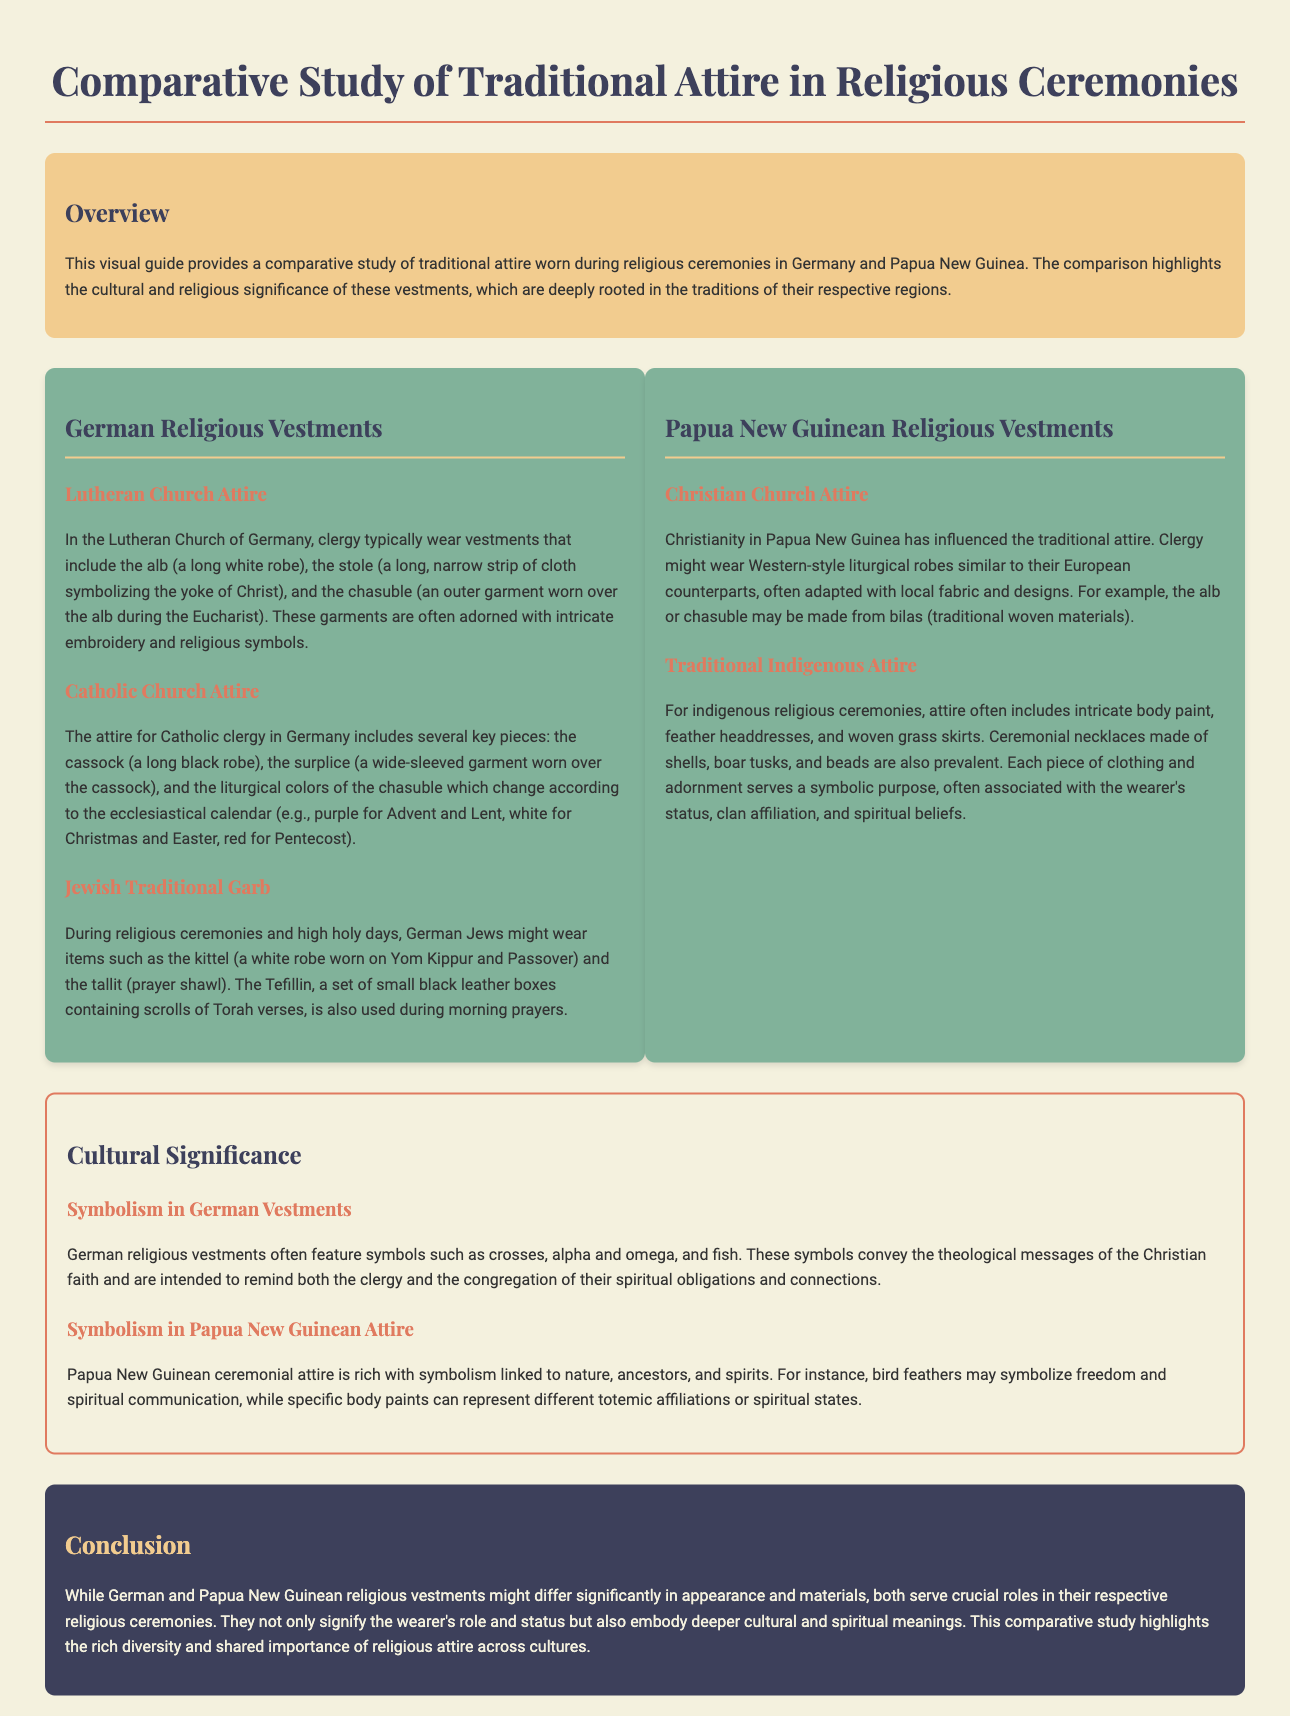What is the primary focus of the visual guide? The visual guide provides a comparative study of traditional attire worn during religious ceremonies in Germany and Papua New Guinea.
Answer: Comparative study of traditional attire What are the three key pieces of attire in the Lutheran Church of Germany? The attire includes the alb, the stole, and the chasuble, which are significant garments in Lutheran services.
Answer: Alb, stole, chasuble Which color is associated with the Catholic Church during Advent and Lent? The document states that purple is the liturgical color used in these seasons, symbolizing preparation and penance.
Answer: Purple What is the name of the ceremonial necklace commonly worn in Papua New Guinean traditional attire? The document mentions that ceremonial necklaces are made of shells, boar tusks, and beads, indicating cultural significance.
Answer: Shells, boar tusks, beads What is the significance of the symbols found in German religious vestments? The symbols convey the theological messages of the Christian faith and remind participants of their spiritual obligations and connections.
Answer: Theological messages What type of attire is influenced by local fabric and designs in Papua New Guinea? The Christian Church attire is adapted with local fabric and designs, reflecting the blending of traditions.
Answer: Western-style liturgical robes How do Papua New Guineans symbolize freedom in their ceremonial attire? Bird feathers are noted as symbols representing freedom and spiritual communication within the cultural context.
Answer: Bird feathers What is a kittel and when is it worn? A kittel is a white robe worn by German Jews during Yom Kippur and Passover, significant in Jewish religious practices.
Answer: White robe, Yom Kippur, Passover 